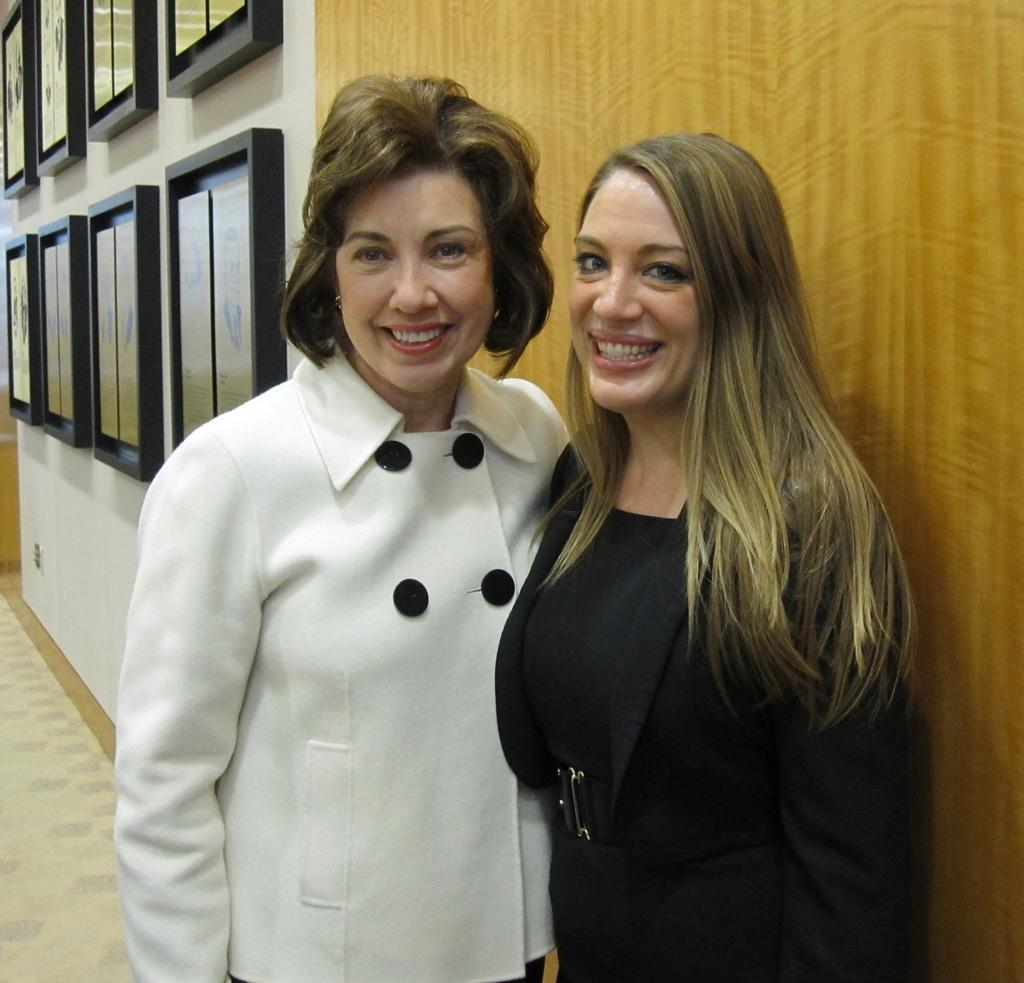How many women are in the image? There are two women in the image. What colors are the dresses of the women? One woman is wearing a white dress, and the other woman is wearing a black dress. What can be seen on the left side of the image? There are photo frames on the left side of the image. Is there a veil covering the head of either woman in the image? No, there is no veil present in the image. What type of rice can be seen in the image? There is no rice present in the image. 